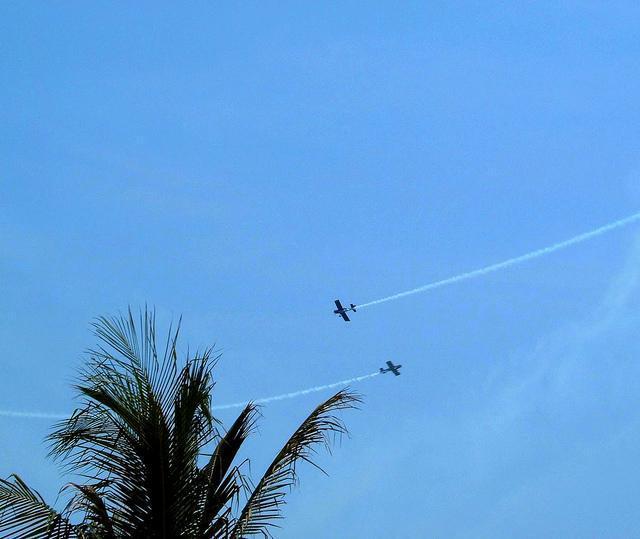How many planes are here?
Give a very brief answer. 2. How many boats with a roof are on the water?
Give a very brief answer. 0. 